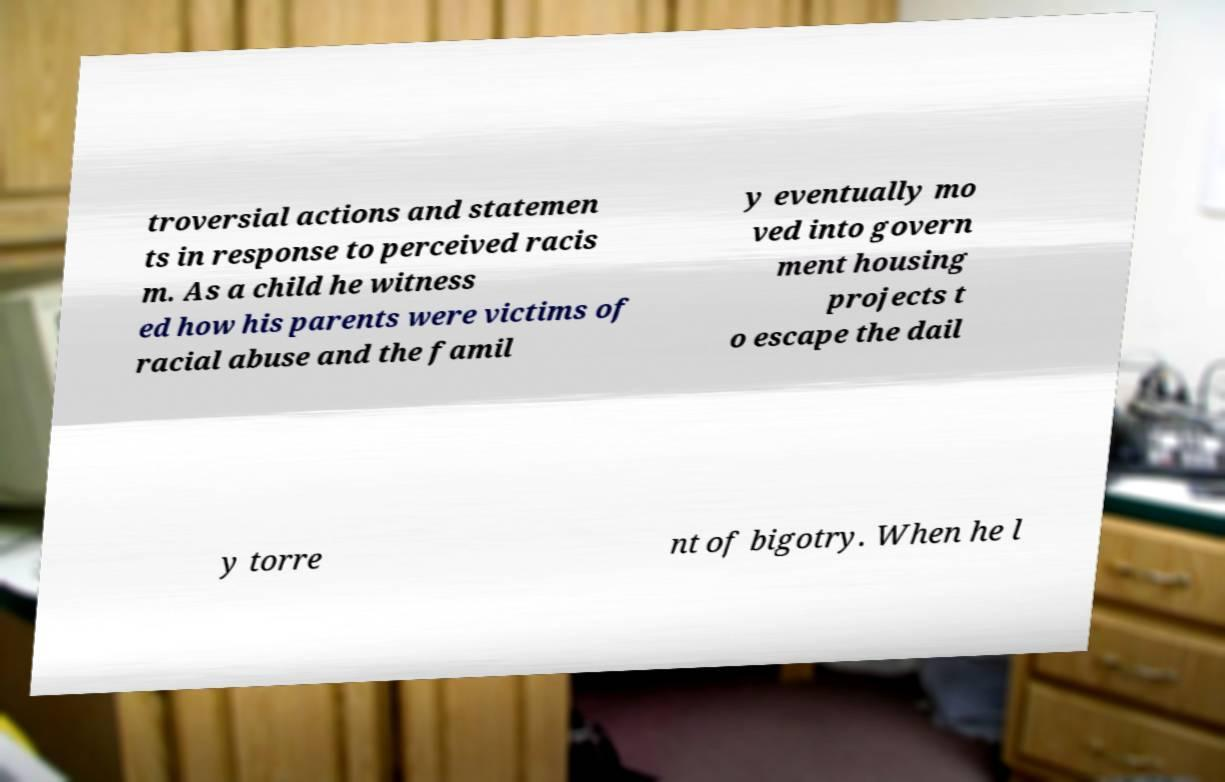Could you assist in decoding the text presented in this image and type it out clearly? troversial actions and statemen ts in response to perceived racis m. As a child he witness ed how his parents were victims of racial abuse and the famil y eventually mo ved into govern ment housing projects t o escape the dail y torre nt of bigotry. When he l 